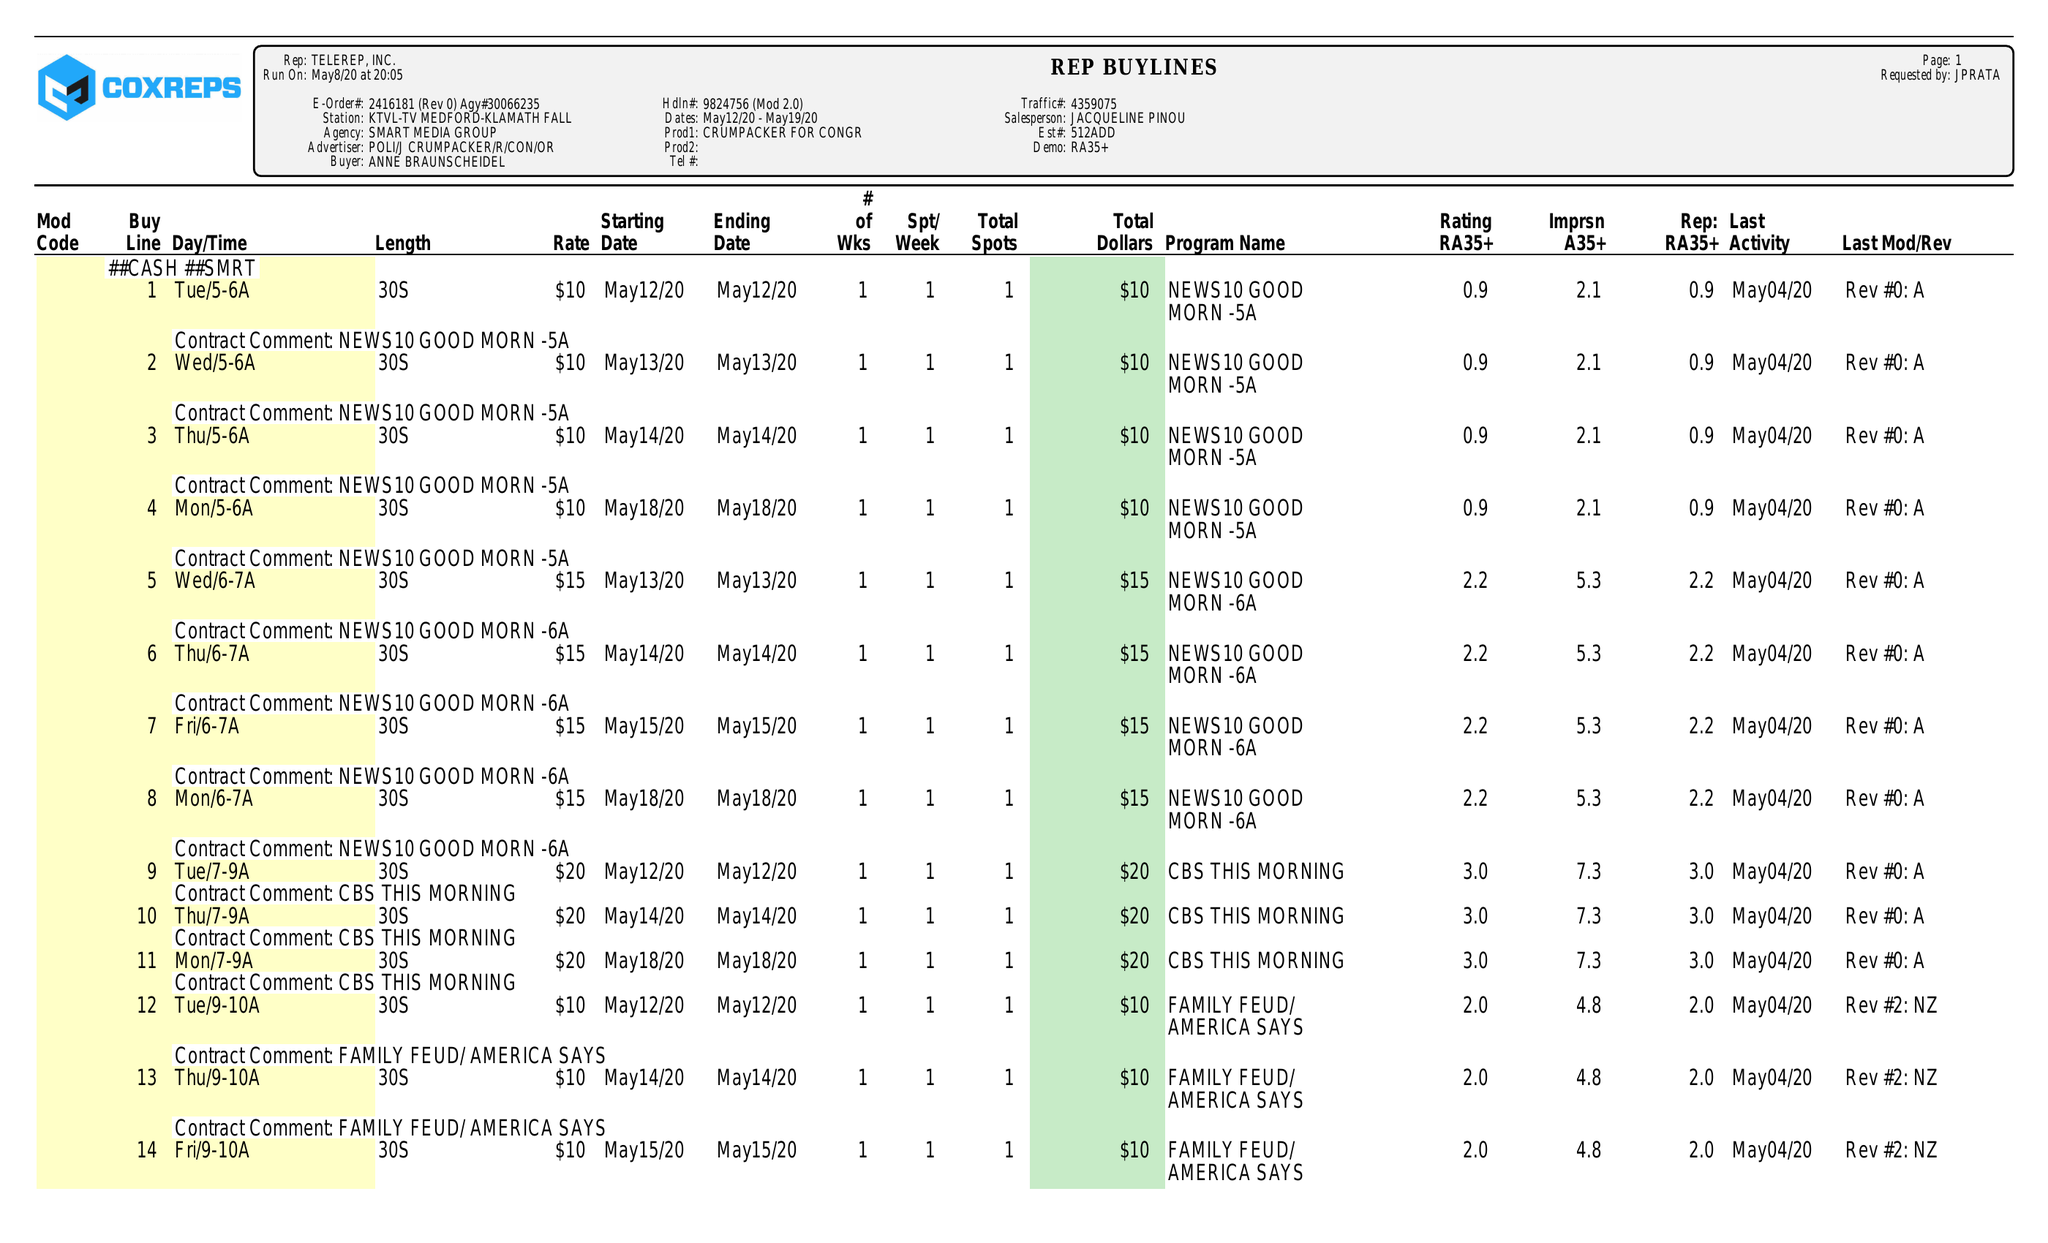What is the value for the advertiser?
Answer the question using a single word or phrase. POLI/JCRUMPACKER/R/CON/OR 